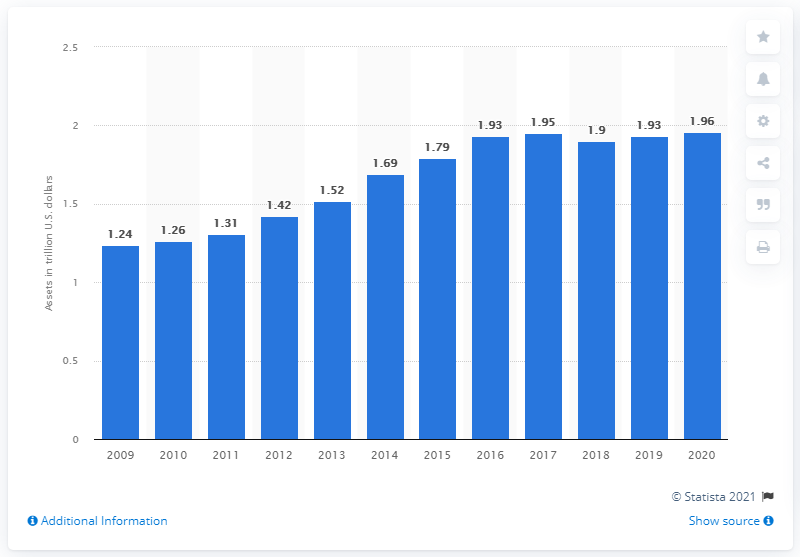List a handful of essential elements in this visual. In 2020, the total assets of Wells Fargo were approximately 1.96 trillion dollars. In 2009, the total assets of Wells Fargo were approximately 1.24 billion dollars. 